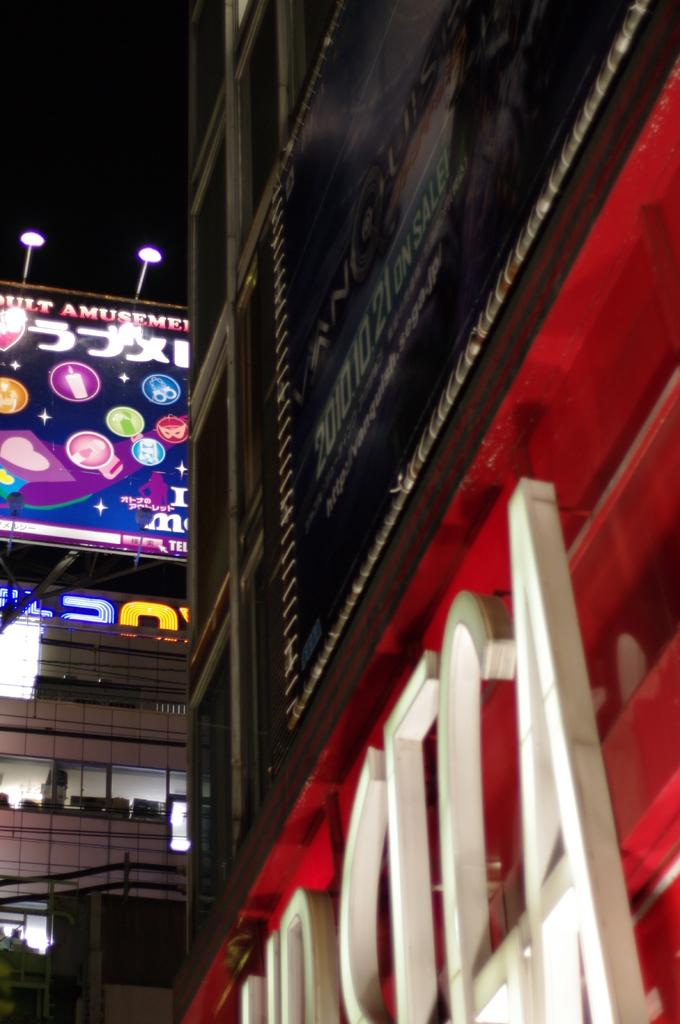What type of structure is present in the image? There is a building in the image. What else can be seen on the building? There is an advertisement visible on the building. What can be seen illuminating the building or its surroundings? Lights are visible in the image. What is visible in the background of the image? The sky is visible in the image. How many clovers can be seen growing on the building in the image? There are no clovers visible on the building in the image. What type of breath is being exhaled by the building in the image? Buildings do not exhale breath, so this question cannot be answered. 